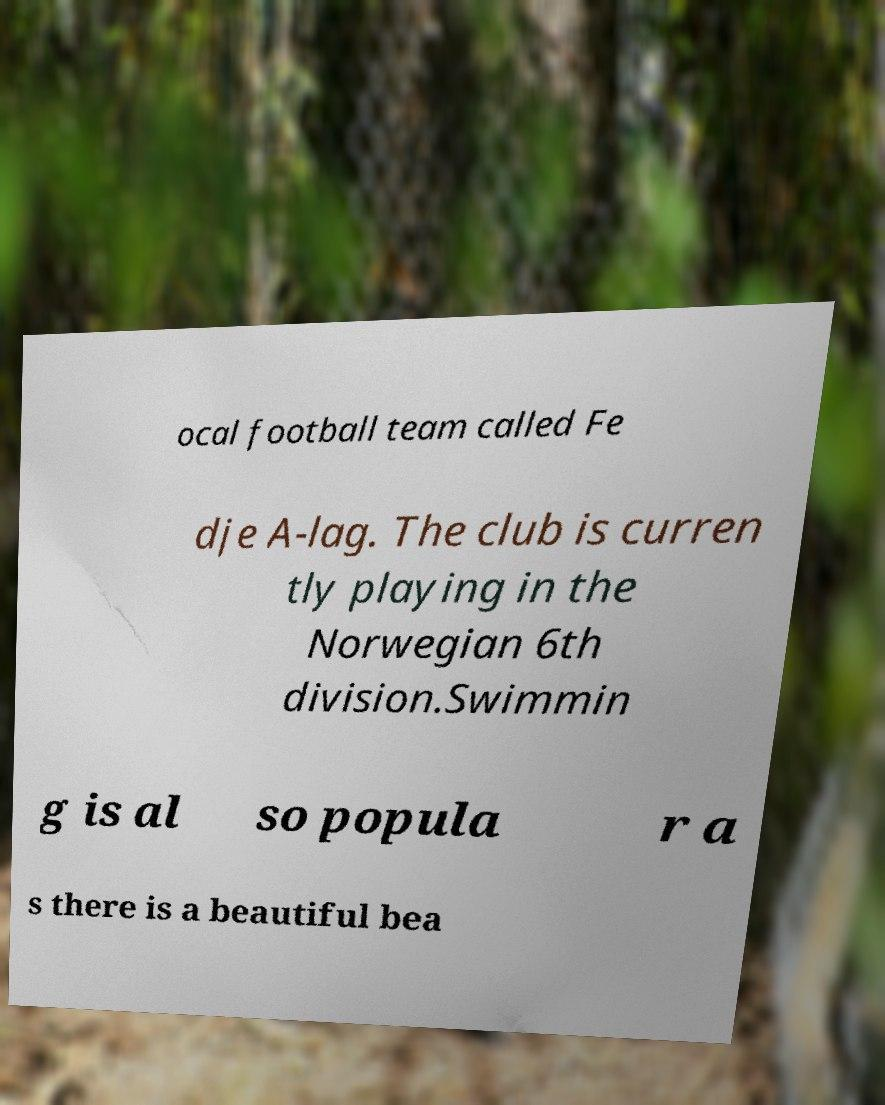I need the written content from this picture converted into text. Can you do that? ocal football team called Fe dje A-lag. The club is curren tly playing in the Norwegian 6th division.Swimmin g is al so popula r a s there is a beautiful bea 